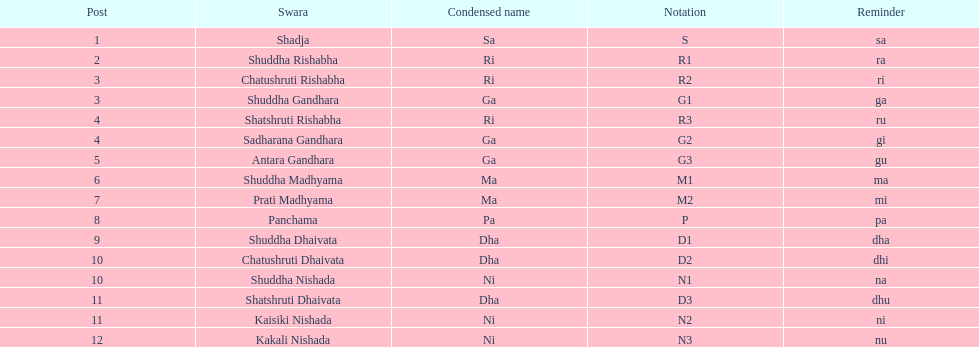On average how many of the swara have a short name that begin with d or g? 6. 